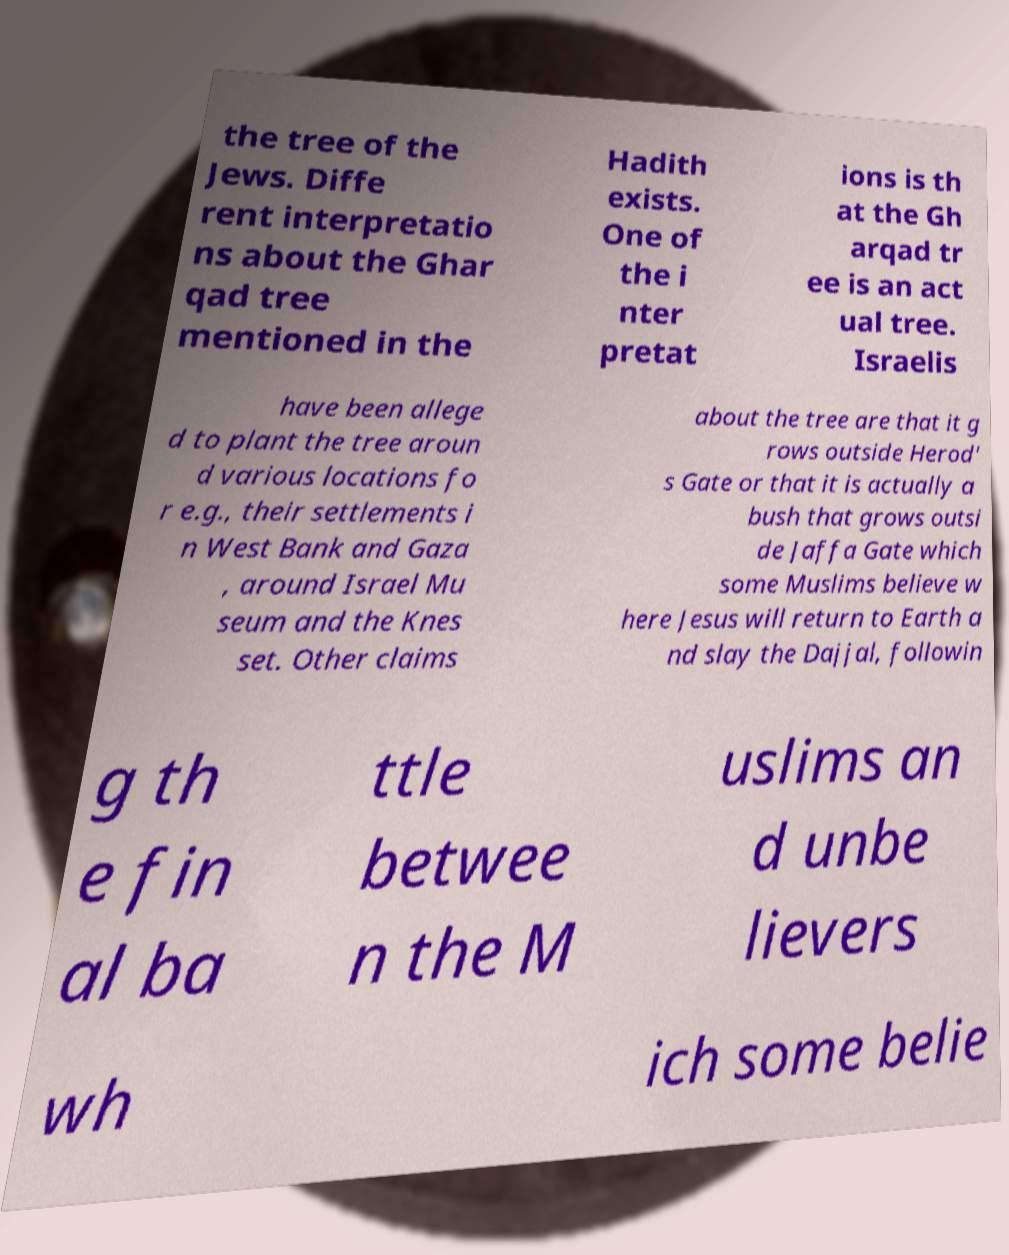I need the written content from this picture converted into text. Can you do that? the tree of the Jews. Diffe rent interpretatio ns about the Ghar qad tree mentioned in the Hadith exists. One of the i nter pretat ions is th at the Gh arqad tr ee is an act ual tree. Israelis have been allege d to plant the tree aroun d various locations fo r e.g., their settlements i n West Bank and Gaza , around Israel Mu seum and the Knes set. Other claims about the tree are that it g rows outside Herod' s Gate or that it is actually a bush that grows outsi de Jaffa Gate which some Muslims believe w here Jesus will return to Earth a nd slay the Dajjal, followin g th e fin al ba ttle betwee n the M uslims an d unbe lievers wh ich some belie 